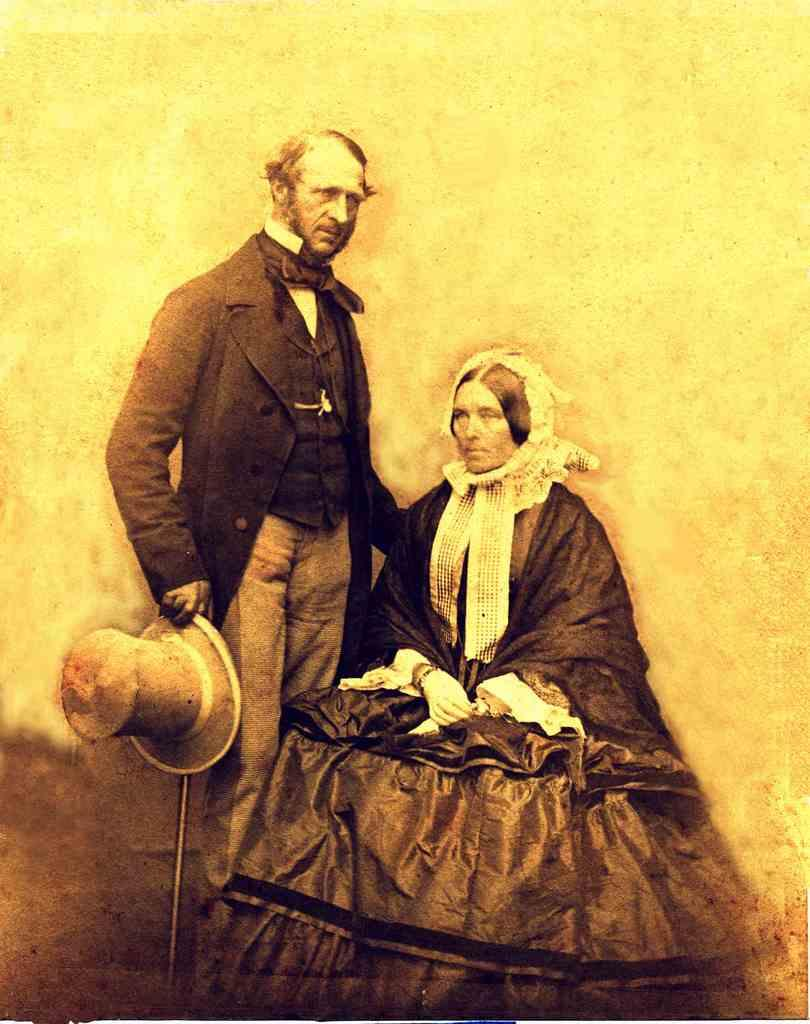What is the woman doing in the image? The woman is sitting in the image. What is the man holding in the image? The man is holding a hat in the image. What is the position of the man in the image? The man is standing in the image. Can you describe the background of the image? The background of the image is unclear. What type of bell can be heard ringing in the image? There is no bell present or ringing in the image. How does the pump function in the image? There is no pump present in the image. 